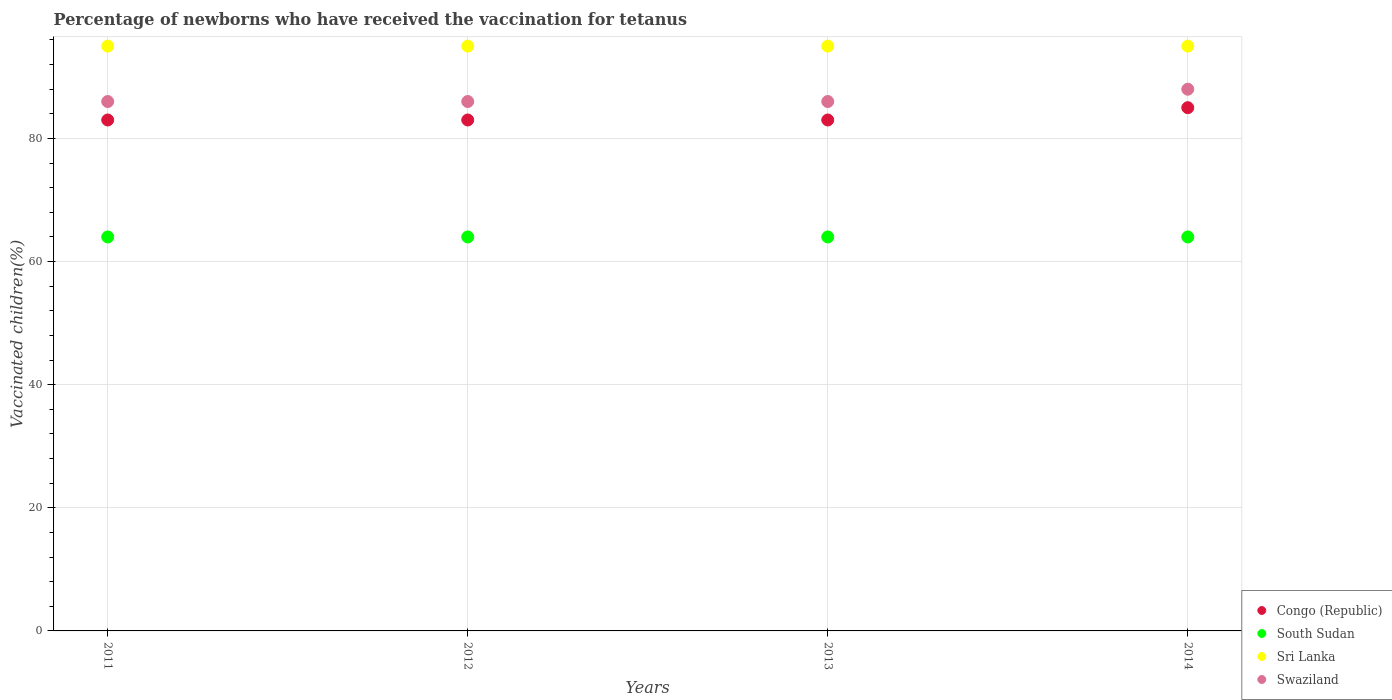Is the number of dotlines equal to the number of legend labels?
Your answer should be very brief. Yes. Across all years, what is the maximum percentage of vaccinated children in Swaziland?
Give a very brief answer. 88. Across all years, what is the minimum percentage of vaccinated children in Sri Lanka?
Your response must be concise. 95. In which year was the percentage of vaccinated children in Swaziland minimum?
Give a very brief answer. 2011. What is the total percentage of vaccinated children in Congo (Republic) in the graph?
Keep it short and to the point. 334. What is the difference between the percentage of vaccinated children in Congo (Republic) in 2013 and that in 2014?
Your answer should be very brief. -2. What is the difference between the percentage of vaccinated children in Swaziland in 2011 and the percentage of vaccinated children in Sri Lanka in 2012?
Offer a very short reply. -9. What is the average percentage of vaccinated children in Congo (Republic) per year?
Keep it short and to the point. 83.5. Is the difference between the percentage of vaccinated children in Swaziland in 2011 and 2013 greater than the difference between the percentage of vaccinated children in South Sudan in 2011 and 2013?
Your response must be concise. No. What is the difference between the highest and the lowest percentage of vaccinated children in Congo (Republic)?
Make the answer very short. 2. Is it the case that in every year, the sum of the percentage of vaccinated children in Sri Lanka and percentage of vaccinated children in South Sudan  is greater than the sum of percentage of vaccinated children in Swaziland and percentage of vaccinated children in Congo (Republic)?
Keep it short and to the point. Yes. Does the percentage of vaccinated children in Congo (Republic) monotonically increase over the years?
Provide a succinct answer. No. Is the percentage of vaccinated children in Congo (Republic) strictly less than the percentage of vaccinated children in South Sudan over the years?
Give a very brief answer. No. Are the values on the major ticks of Y-axis written in scientific E-notation?
Your answer should be very brief. No. Where does the legend appear in the graph?
Your answer should be very brief. Bottom right. How many legend labels are there?
Your response must be concise. 4. What is the title of the graph?
Give a very brief answer. Percentage of newborns who have received the vaccination for tetanus. Does "South Sudan" appear as one of the legend labels in the graph?
Your response must be concise. Yes. What is the label or title of the Y-axis?
Ensure brevity in your answer.  Vaccinated children(%). What is the Vaccinated children(%) in South Sudan in 2011?
Give a very brief answer. 64. What is the Vaccinated children(%) of Swaziland in 2011?
Your answer should be very brief. 86. What is the Vaccinated children(%) in Congo (Republic) in 2012?
Provide a short and direct response. 83. What is the Vaccinated children(%) of Sri Lanka in 2012?
Your response must be concise. 95. What is the Vaccinated children(%) of Swaziland in 2012?
Your answer should be very brief. 86. What is the Vaccinated children(%) of Congo (Republic) in 2013?
Give a very brief answer. 83. What is the Vaccinated children(%) of Sri Lanka in 2013?
Your answer should be compact. 95. What is the Vaccinated children(%) of Swaziland in 2013?
Your answer should be very brief. 86. What is the Vaccinated children(%) in South Sudan in 2014?
Your response must be concise. 64. What is the Vaccinated children(%) of Swaziland in 2014?
Keep it short and to the point. 88. Across all years, what is the maximum Vaccinated children(%) of Congo (Republic)?
Ensure brevity in your answer.  85. Across all years, what is the maximum Vaccinated children(%) in Sri Lanka?
Give a very brief answer. 95. Across all years, what is the minimum Vaccinated children(%) in South Sudan?
Your response must be concise. 64. Across all years, what is the minimum Vaccinated children(%) of Swaziland?
Provide a succinct answer. 86. What is the total Vaccinated children(%) of Congo (Republic) in the graph?
Offer a very short reply. 334. What is the total Vaccinated children(%) in South Sudan in the graph?
Your answer should be very brief. 256. What is the total Vaccinated children(%) in Sri Lanka in the graph?
Give a very brief answer. 380. What is the total Vaccinated children(%) of Swaziland in the graph?
Your response must be concise. 346. What is the difference between the Vaccinated children(%) in Congo (Republic) in 2011 and that in 2012?
Provide a short and direct response. 0. What is the difference between the Vaccinated children(%) of South Sudan in 2011 and that in 2012?
Your answer should be very brief. 0. What is the difference between the Vaccinated children(%) in Sri Lanka in 2011 and that in 2012?
Offer a terse response. 0. What is the difference between the Vaccinated children(%) of Swaziland in 2011 and that in 2012?
Keep it short and to the point. 0. What is the difference between the Vaccinated children(%) of Sri Lanka in 2011 and that in 2013?
Ensure brevity in your answer.  0. What is the difference between the Vaccinated children(%) of Sri Lanka in 2011 and that in 2014?
Your answer should be very brief. 0. What is the difference between the Vaccinated children(%) in Swaziland in 2011 and that in 2014?
Your answer should be compact. -2. What is the difference between the Vaccinated children(%) in Congo (Republic) in 2012 and that in 2013?
Your response must be concise. 0. What is the difference between the Vaccinated children(%) of Sri Lanka in 2012 and that in 2013?
Offer a terse response. 0. What is the difference between the Vaccinated children(%) of Swaziland in 2012 and that in 2013?
Offer a terse response. 0. What is the difference between the Vaccinated children(%) in South Sudan in 2012 and that in 2014?
Ensure brevity in your answer.  0. What is the difference between the Vaccinated children(%) in Sri Lanka in 2012 and that in 2014?
Your response must be concise. 0. What is the difference between the Vaccinated children(%) of Congo (Republic) in 2013 and that in 2014?
Provide a short and direct response. -2. What is the difference between the Vaccinated children(%) of Swaziland in 2013 and that in 2014?
Keep it short and to the point. -2. What is the difference between the Vaccinated children(%) in South Sudan in 2011 and the Vaccinated children(%) in Sri Lanka in 2012?
Your answer should be very brief. -31. What is the difference between the Vaccinated children(%) of South Sudan in 2011 and the Vaccinated children(%) of Swaziland in 2012?
Your answer should be very brief. -22. What is the difference between the Vaccinated children(%) of Congo (Republic) in 2011 and the Vaccinated children(%) of South Sudan in 2013?
Give a very brief answer. 19. What is the difference between the Vaccinated children(%) in Congo (Republic) in 2011 and the Vaccinated children(%) in Swaziland in 2013?
Offer a terse response. -3. What is the difference between the Vaccinated children(%) in South Sudan in 2011 and the Vaccinated children(%) in Sri Lanka in 2013?
Ensure brevity in your answer.  -31. What is the difference between the Vaccinated children(%) of South Sudan in 2011 and the Vaccinated children(%) of Swaziland in 2013?
Your answer should be very brief. -22. What is the difference between the Vaccinated children(%) of Sri Lanka in 2011 and the Vaccinated children(%) of Swaziland in 2013?
Ensure brevity in your answer.  9. What is the difference between the Vaccinated children(%) in Congo (Republic) in 2011 and the Vaccinated children(%) in Swaziland in 2014?
Give a very brief answer. -5. What is the difference between the Vaccinated children(%) of South Sudan in 2011 and the Vaccinated children(%) of Sri Lanka in 2014?
Offer a terse response. -31. What is the difference between the Vaccinated children(%) in South Sudan in 2011 and the Vaccinated children(%) in Swaziland in 2014?
Your answer should be compact. -24. What is the difference between the Vaccinated children(%) of Sri Lanka in 2011 and the Vaccinated children(%) of Swaziland in 2014?
Your response must be concise. 7. What is the difference between the Vaccinated children(%) of Congo (Republic) in 2012 and the Vaccinated children(%) of Swaziland in 2013?
Offer a very short reply. -3. What is the difference between the Vaccinated children(%) in South Sudan in 2012 and the Vaccinated children(%) in Sri Lanka in 2013?
Provide a short and direct response. -31. What is the difference between the Vaccinated children(%) in South Sudan in 2012 and the Vaccinated children(%) in Swaziland in 2013?
Offer a terse response. -22. What is the difference between the Vaccinated children(%) of Congo (Republic) in 2012 and the Vaccinated children(%) of Swaziland in 2014?
Give a very brief answer. -5. What is the difference between the Vaccinated children(%) of South Sudan in 2012 and the Vaccinated children(%) of Sri Lanka in 2014?
Make the answer very short. -31. What is the difference between the Vaccinated children(%) of South Sudan in 2013 and the Vaccinated children(%) of Sri Lanka in 2014?
Give a very brief answer. -31. What is the difference between the Vaccinated children(%) in South Sudan in 2013 and the Vaccinated children(%) in Swaziland in 2014?
Make the answer very short. -24. What is the difference between the Vaccinated children(%) in Sri Lanka in 2013 and the Vaccinated children(%) in Swaziland in 2014?
Ensure brevity in your answer.  7. What is the average Vaccinated children(%) in Congo (Republic) per year?
Offer a very short reply. 83.5. What is the average Vaccinated children(%) of South Sudan per year?
Make the answer very short. 64. What is the average Vaccinated children(%) in Sri Lanka per year?
Provide a short and direct response. 95. What is the average Vaccinated children(%) in Swaziland per year?
Your response must be concise. 86.5. In the year 2011, what is the difference between the Vaccinated children(%) in Congo (Republic) and Vaccinated children(%) in Sri Lanka?
Your response must be concise. -12. In the year 2011, what is the difference between the Vaccinated children(%) in South Sudan and Vaccinated children(%) in Sri Lanka?
Your answer should be very brief. -31. In the year 2011, what is the difference between the Vaccinated children(%) in South Sudan and Vaccinated children(%) in Swaziland?
Your response must be concise. -22. In the year 2012, what is the difference between the Vaccinated children(%) of Congo (Republic) and Vaccinated children(%) of Sri Lanka?
Make the answer very short. -12. In the year 2012, what is the difference between the Vaccinated children(%) of Congo (Republic) and Vaccinated children(%) of Swaziland?
Offer a very short reply. -3. In the year 2012, what is the difference between the Vaccinated children(%) in South Sudan and Vaccinated children(%) in Sri Lanka?
Ensure brevity in your answer.  -31. In the year 2012, what is the difference between the Vaccinated children(%) in Sri Lanka and Vaccinated children(%) in Swaziland?
Give a very brief answer. 9. In the year 2013, what is the difference between the Vaccinated children(%) of Congo (Republic) and Vaccinated children(%) of South Sudan?
Provide a succinct answer. 19. In the year 2013, what is the difference between the Vaccinated children(%) of Congo (Republic) and Vaccinated children(%) of Sri Lanka?
Offer a very short reply. -12. In the year 2013, what is the difference between the Vaccinated children(%) of South Sudan and Vaccinated children(%) of Sri Lanka?
Your response must be concise. -31. In the year 2014, what is the difference between the Vaccinated children(%) in Congo (Republic) and Vaccinated children(%) in Swaziland?
Provide a short and direct response. -3. In the year 2014, what is the difference between the Vaccinated children(%) in South Sudan and Vaccinated children(%) in Sri Lanka?
Your response must be concise. -31. In the year 2014, what is the difference between the Vaccinated children(%) in Sri Lanka and Vaccinated children(%) in Swaziland?
Your response must be concise. 7. What is the ratio of the Vaccinated children(%) in Swaziland in 2011 to that in 2012?
Offer a terse response. 1. What is the ratio of the Vaccinated children(%) in Congo (Republic) in 2011 to that in 2013?
Keep it short and to the point. 1. What is the ratio of the Vaccinated children(%) of South Sudan in 2011 to that in 2013?
Your answer should be compact. 1. What is the ratio of the Vaccinated children(%) of Swaziland in 2011 to that in 2013?
Your answer should be compact. 1. What is the ratio of the Vaccinated children(%) in Congo (Republic) in 2011 to that in 2014?
Your answer should be very brief. 0.98. What is the ratio of the Vaccinated children(%) of Swaziland in 2011 to that in 2014?
Your response must be concise. 0.98. What is the ratio of the Vaccinated children(%) of Congo (Republic) in 2012 to that in 2013?
Make the answer very short. 1. What is the ratio of the Vaccinated children(%) in Sri Lanka in 2012 to that in 2013?
Offer a very short reply. 1. What is the ratio of the Vaccinated children(%) of Congo (Republic) in 2012 to that in 2014?
Keep it short and to the point. 0.98. What is the ratio of the Vaccinated children(%) of Sri Lanka in 2012 to that in 2014?
Give a very brief answer. 1. What is the ratio of the Vaccinated children(%) of Swaziland in 2012 to that in 2014?
Keep it short and to the point. 0.98. What is the ratio of the Vaccinated children(%) in Congo (Republic) in 2013 to that in 2014?
Your answer should be very brief. 0.98. What is the ratio of the Vaccinated children(%) of South Sudan in 2013 to that in 2014?
Your answer should be very brief. 1. What is the ratio of the Vaccinated children(%) in Sri Lanka in 2013 to that in 2014?
Your response must be concise. 1. What is the ratio of the Vaccinated children(%) in Swaziland in 2013 to that in 2014?
Keep it short and to the point. 0.98. What is the difference between the highest and the second highest Vaccinated children(%) of Congo (Republic)?
Provide a succinct answer. 2. What is the difference between the highest and the second highest Vaccinated children(%) of South Sudan?
Provide a short and direct response. 0. What is the difference between the highest and the lowest Vaccinated children(%) of Congo (Republic)?
Provide a short and direct response. 2. What is the difference between the highest and the lowest Vaccinated children(%) in Sri Lanka?
Your answer should be compact. 0. 